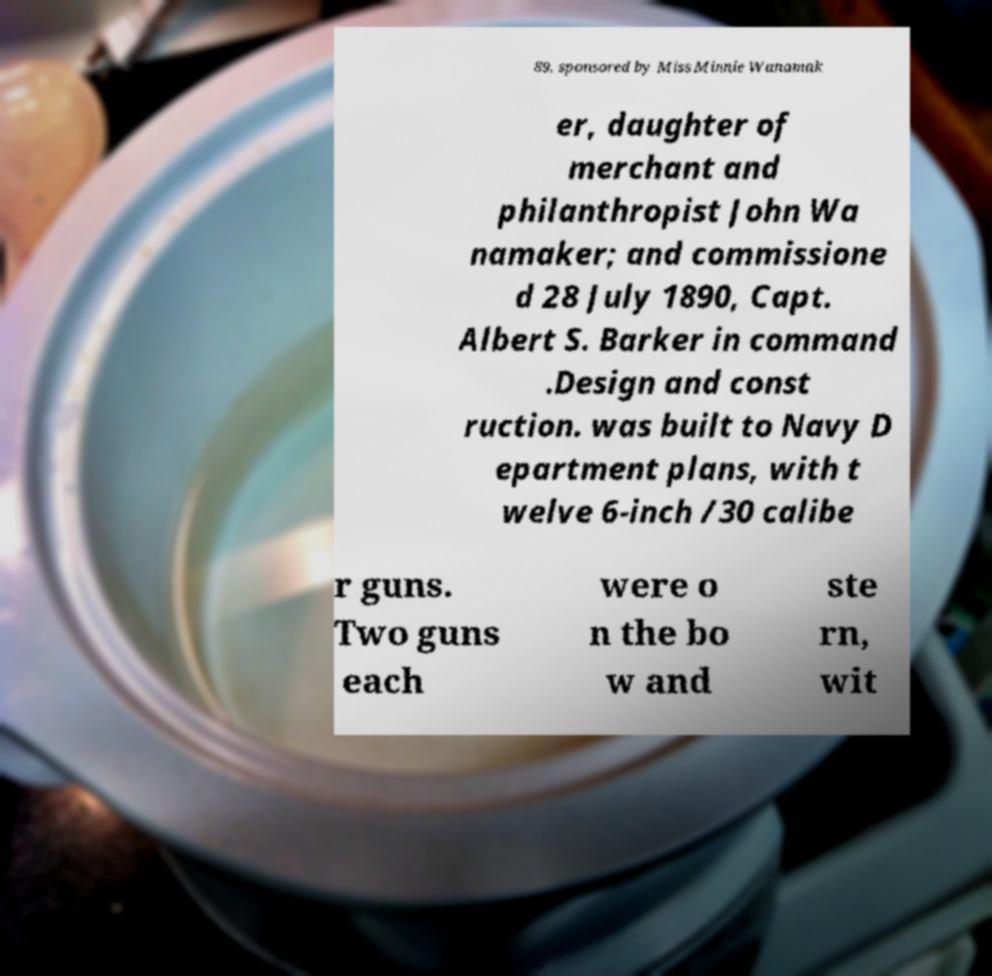Could you extract and type out the text from this image? 89, sponsored by Miss Minnie Wanamak er, daughter of merchant and philanthropist John Wa namaker; and commissione d 28 July 1890, Capt. Albert S. Barker in command .Design and const ruction. was built to Navy D epartment plans, with t welve 6-inch /30 calibe r guns. Two guns each were o n the bo w and ste rn, wit 